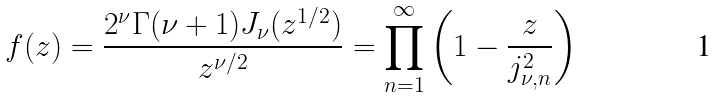Convert formula to latex. <formula><loc_0><loc_0><loc_500><loc_500>f ( z ) & = \frac { 2 ^ { \nu } \Gamma ( \nu + 1 ) J _ { \nu } ( z ^ { 1 / 2 } ) } { z ^ { \nu / 2 } } = \prod _ { n = 1 } ^ { \infty } \left ( 1 - \frac { z } { j _ { \nu , n } ^ { 2 } } \right )</formula> 